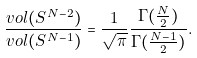<formula> <loc_0><loc_0><loc_500><loc_500>\frac { v o l ( S ^ { N - 2 } ) } { v o l ( S ^ { N - 1 } ) } = \frac { 1 } { \sqrt { \pi } } \frac { \Gamma ( \frac { N } { 2 } ) } { \Gamma ( \frac { N - 1 } { 2 } ) } .</formula> 